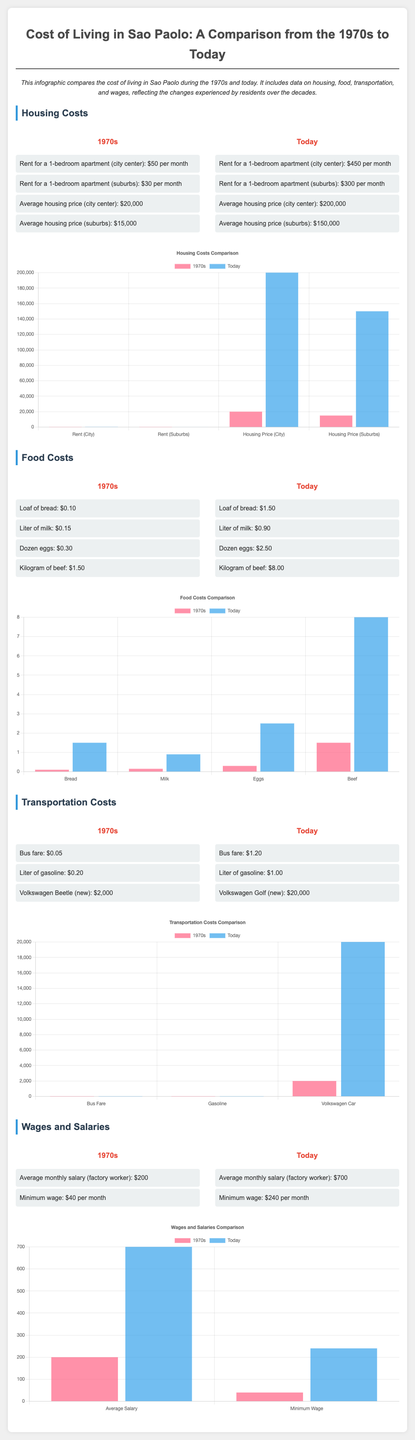what was the rent for a 1-bedroom apartment in the city center in the 1970s? The rent for a 1-bedroom apartment in the city center during the 1970s was $50 per month.
Answer: $50 per month what is the average housing price in the suburbs today? The average housing price in the suburbs today is $150,000.
Answer: $150,000 how much did a kilogram of beef cost in the 1970s? A kilogram of beef in the 1970s cost $1.50.
Answer: $1.50 what is the current bus fare? The current bus fare is $1.20.
Answer: $1.20 what was the average monthly salary for a factory worker in the 1970s? The average monthly salary for a factory worker in the 1970s was $200.
Answer: $200 how much has the rent for a 1-bedroom apartment in the city center increased from the 1970s to today? The rent for a 1-bedroom apartment in the city center increased from $50 to $450, which is an increase of $400.
Answer: $400 what is the percentage increase in the price of milk from the 1970s to today? The price of milk increased from $0.15 to $0.90, which is a percentage increase of 500%.
Answer: 500% what type of car has been compared in transportation costs? The car compared in transportation costs is the Volkswagen Beetle in the 1970s and the Volkswagen Golf today.
Answer: Volkswagen Beetle and Volkswagen Golf how does the minimum wage today compare to the minimum wage in the 1970s? The minimum wage today is $240, compared to $40 in the 1970s, showing an increase of $200.
Answer: $200 increase 